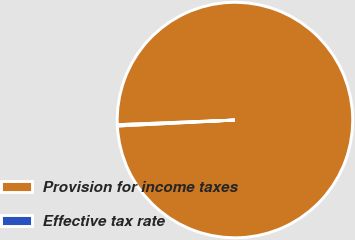Convert chart to OTSL. <chart><loc_0><loc_0><loc_500><loc_500><pie_chart><fcel>Provision for income taxes<fcel>Effective tax rate<nl><fcel>99.82%<fcel>0.18%<nl></chart> 